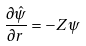Convert formula to latex. <formula><loc_0><loc_0><loc_500><loc_500>\frac { \partial \hat { \psi } } { \partial r } = - Z \psi</formula> 